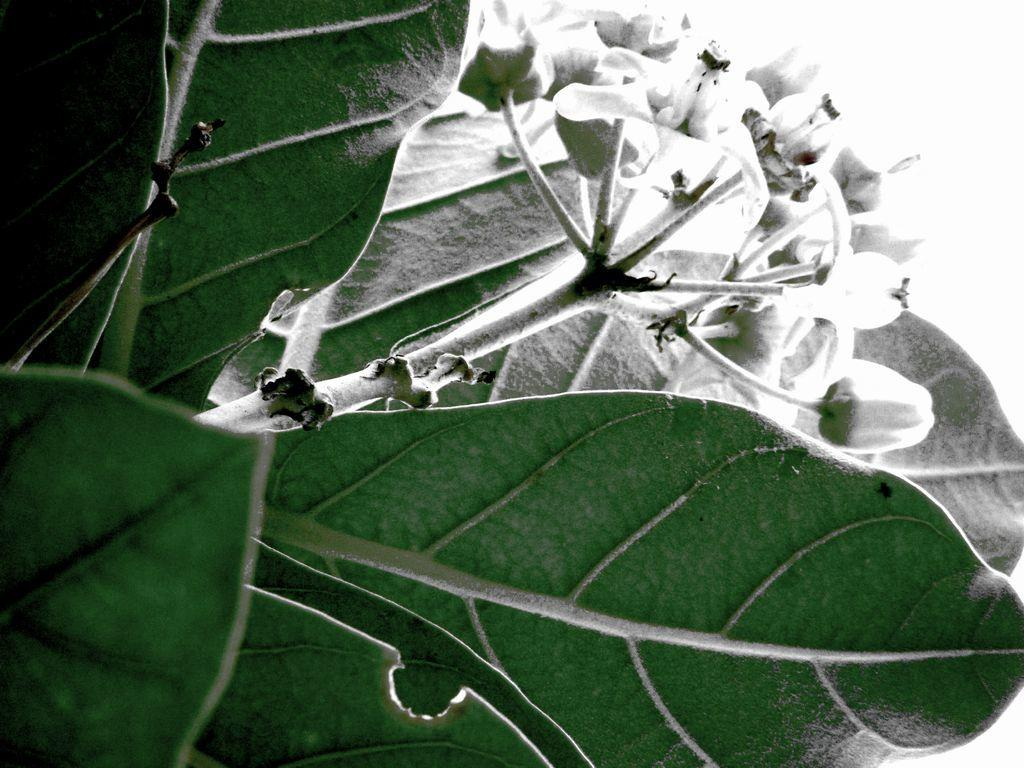What type of plant material is present in the image? The image contains leaves. Can you describe the leaves in more detail? The leaves have buds. How many fangs can be seen on the leaves in the image? There are no fangs present on the leaves in the image. What type of corn is growing in the background of the image? There is no corn present in the image; it only contains leaves with buds. 